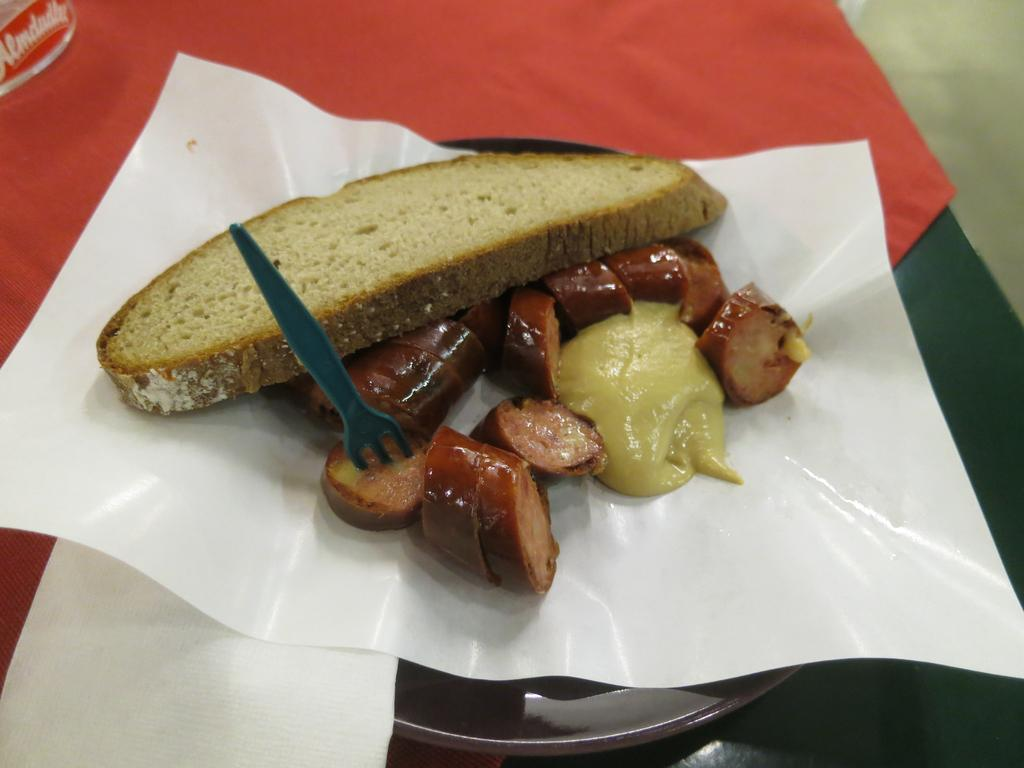What is located in the center of the image? There is a table in the center of the image. What is covering the table? There is a cloth on the table. What is placed on the table along with the cloth? There is a plate and a fork on the table. What can be used for cleaning or wiping on the table? There are tissue papers on the table. What is the purpose of the table in the image? The table is likely set for a meal, as there are food items on the table. What type of cart is visible in the image? There is no cart present in the image. How many buckets are used to hold the food items on the table? There are no buckets present in the image; the food items are on a plate. 